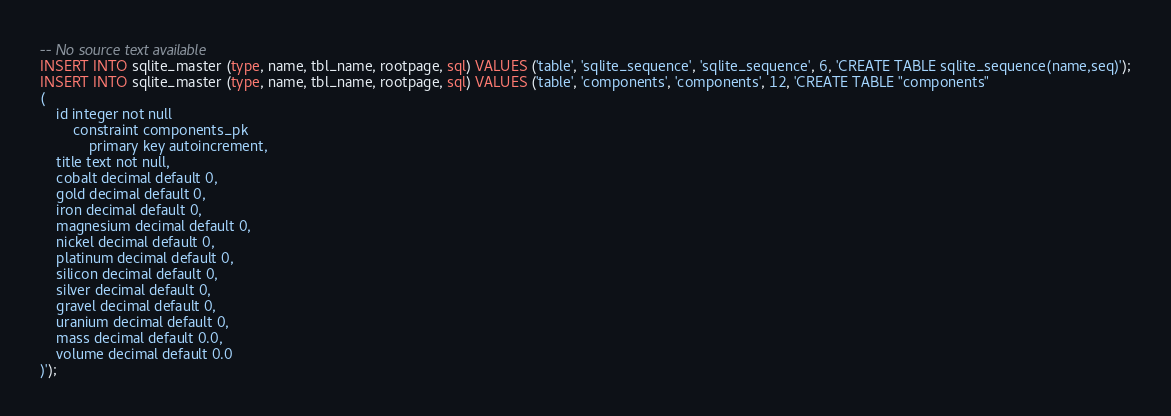Convert code to text. <code><loc_0><loc_0><loc_500><loc_500><_SQL_>-- No source text available
INSERT INTO sqlite_master (type, name, tbl_name, rootpage, sql) VALUES ('table', 'sqlite_sequence', 'sqlite_sequence', 6, 'CREATE TABLE sqlite_sequence(name,seq)');
INSERT INTO sqlite_master (type, name, tbl_name, rootpage, sql) VALUES ('table', 'components', 'components', 12, 'CREATE TABLE "components"
(
	id integer not null
		constraint components_pk
			primary key autoincrement,
	title text not null,
	cobalt decimal default 0,
	gold decimal default 0,
	iron decimal default 0,
	magnesium decimal default 0,
	nickel decimal default 0,
	platinum decimal default 0,
	silicon decimal default 0,
	silver decimal default 0,
	gravel decimal default 0,
	uranium decimal default 0,
	mass decimal default 0.0,
	volume decimal default 0.0
)');</code> 